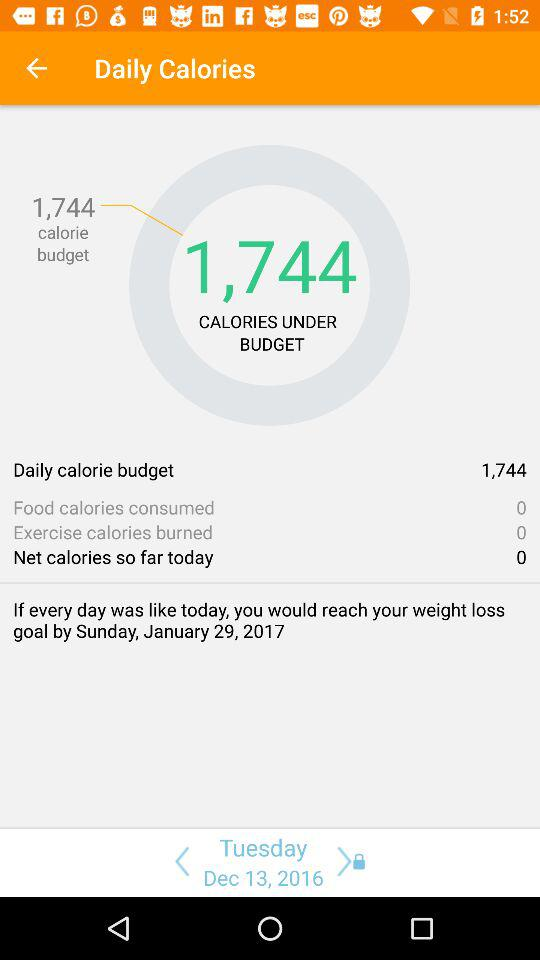How many calories are you under budget by?
Answer the question using a single word or phrase. 1,744 